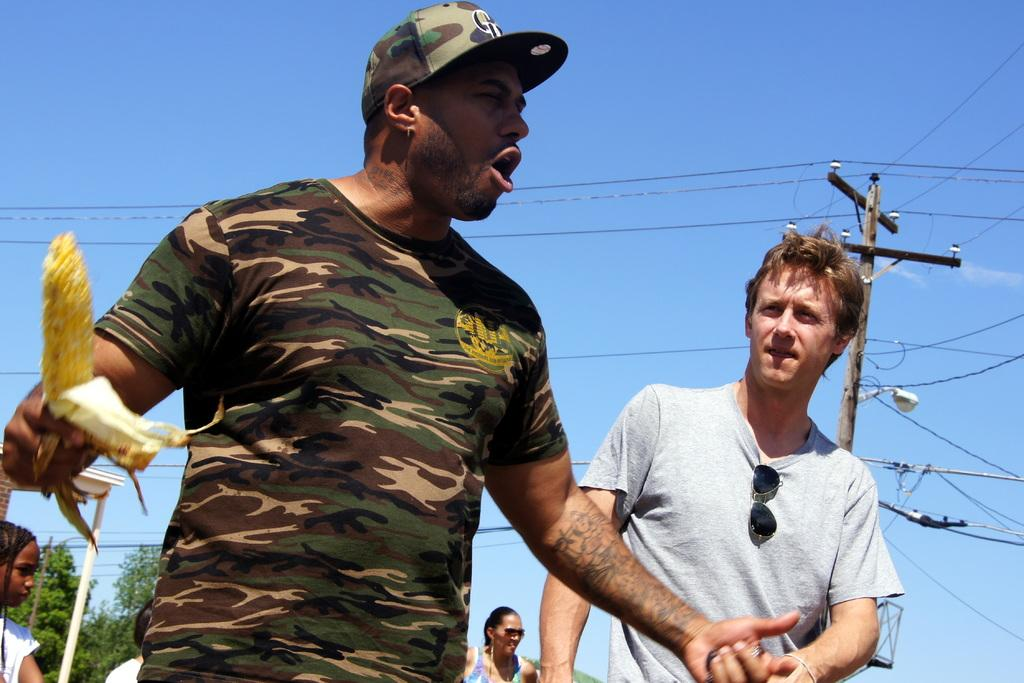How many people are in the image? There are people in the image, but the exact number is not specified. What is one person holding in the image? One person is holding a maize in the image. What can be seen in the image besides the people and maize? There are poles, wires, a light, trees, and the sky visible in the image. What color is the sky in the background of the image? The sky is visible in the background of the image, and it is blue in color. What type of lunch is being prepared on the map in the image? There is no map or lunch preparation visible in the image. How many oranges are on the ground near the trees in the image? There are no oranges present in the image. 